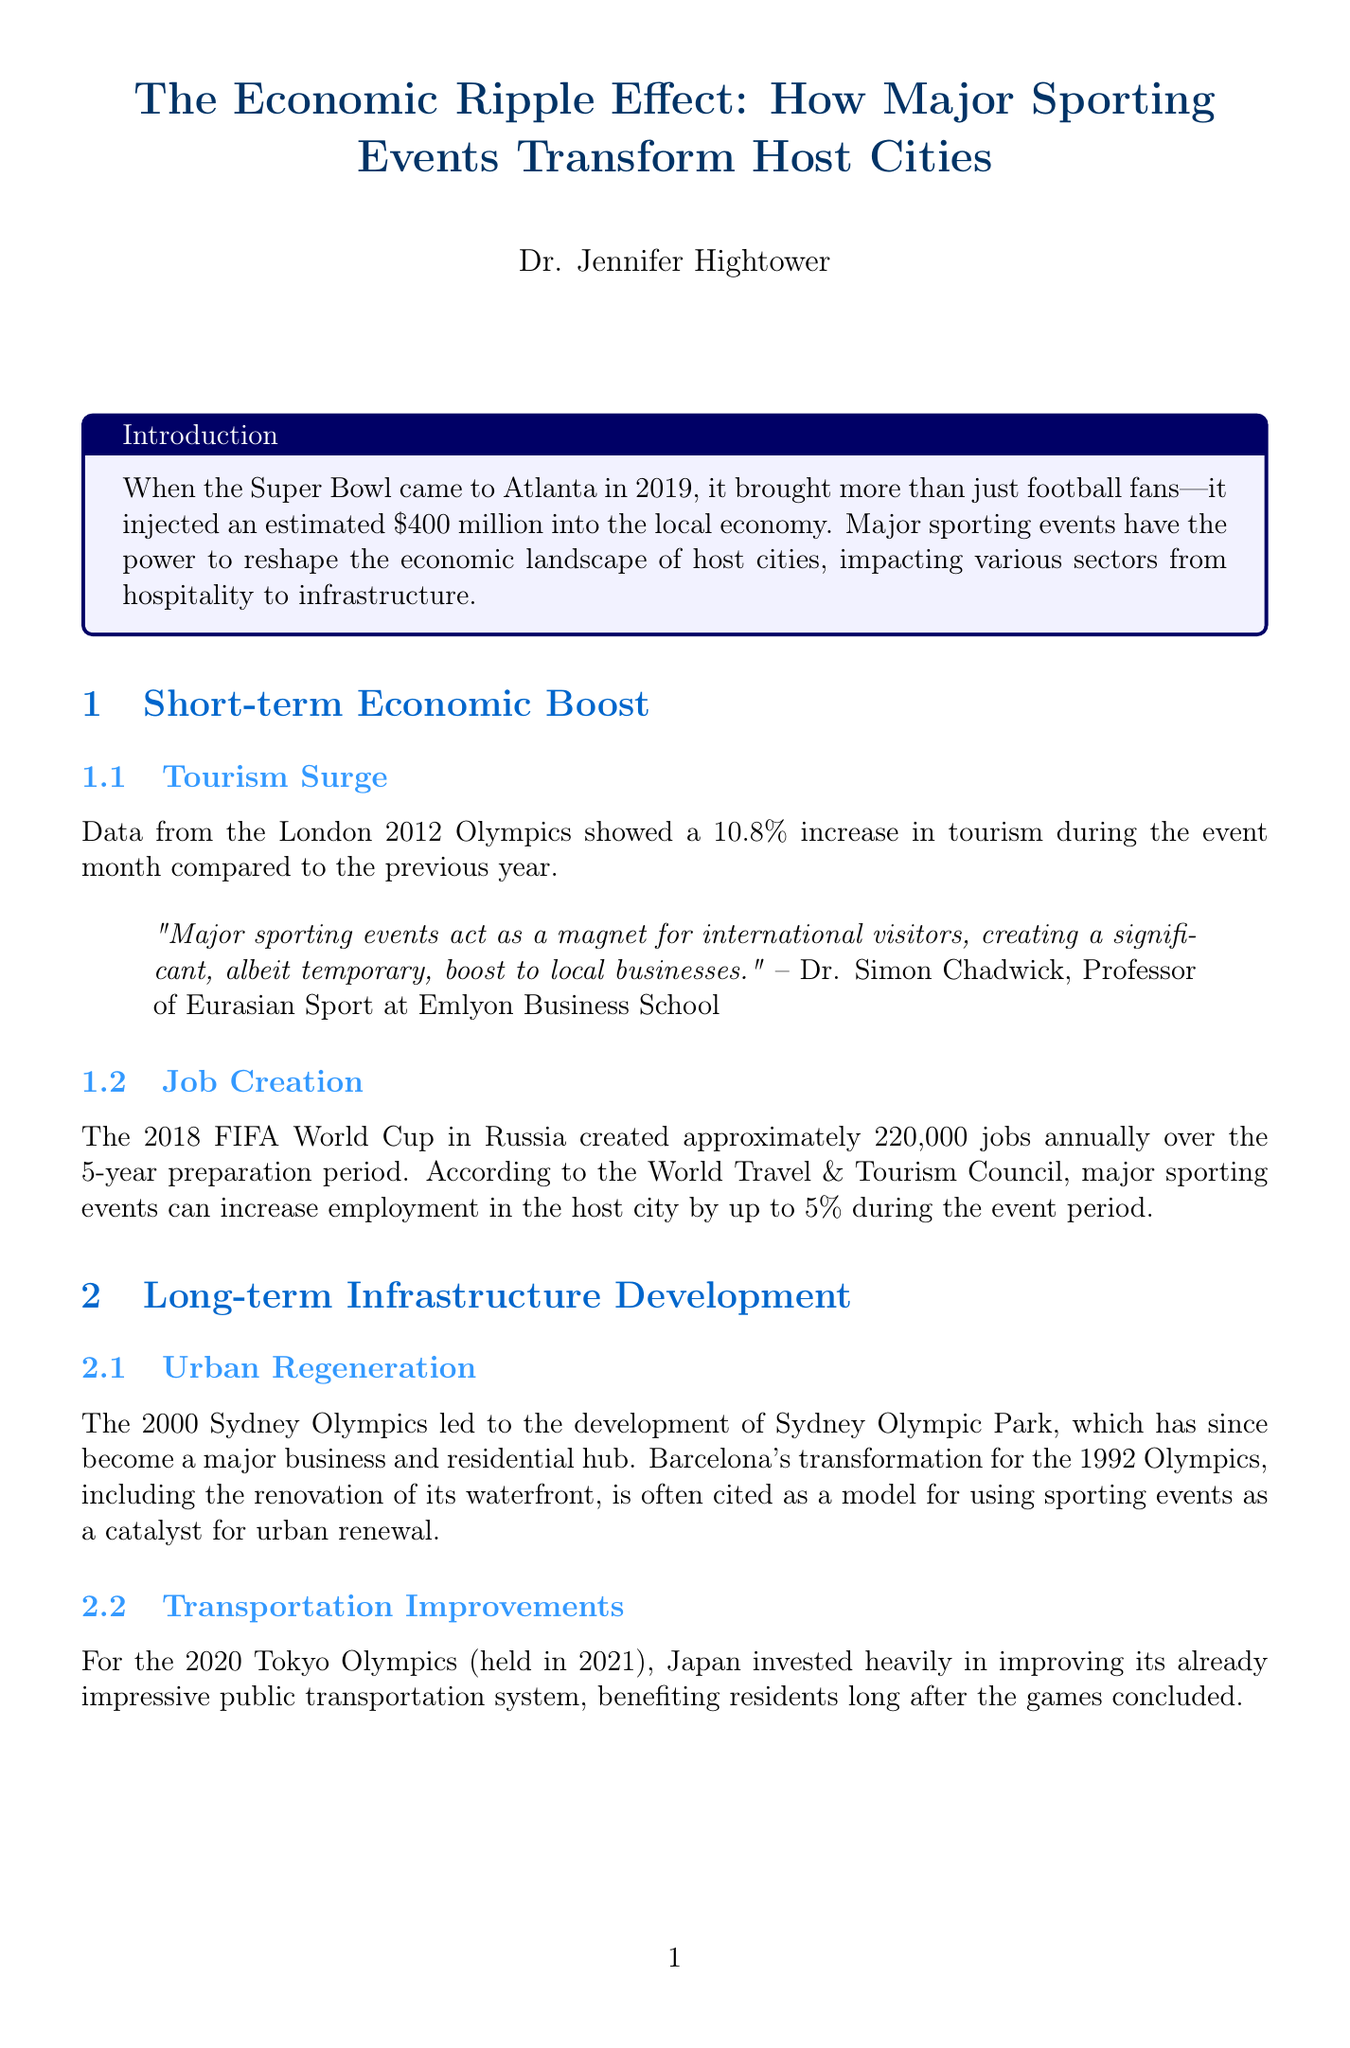What was the estimated economic injection from the Super Bowl in Atlanta? The document states that the Super Bowl injected an estimated $400 million into the local economy.
Answer: $400 million What percentage increase in tourism was recorded during the London 2012 Olympics? Data from the document shows a 10.8% increase in tourism during the event month compared to the previous year.
Answer: 10.8% How many jobs were created annually during the 2018 FIFA World Cup in Russia? The document mentions that the World Cup created approximately 220,000 jobs annually over the 5-year preparation period.
Answer: 220,000 What major development resulted from the 2000 Sydney Olympics? The document notes that the 2000 Sydney Olympics led to the development of Sydney Olympic Park, which became a major business and residential hub.
Answer: Sydney Olympic Park What is the term used for costly facilities that see little use after major events? The document states that the term "White Elephant Syndrome" refers to such facilities.
Answer: White Elephant Syndrome Who is the author of this report? The document clearly lists the author as Dr. Jennifer Hightower.
Answer: Dr. Jennifer Hightower What is the primary concern related to the 2014 Sochi Winter Olympics? The report highlights "Cost Overruns" as a primary concern due to the budget exceeding initial projections.
Answer: Cost Overruns How many people were reached by the global audience of the 2018 FIFA World Cup? The document indicates that the World Cup reached a global in-home television audience of 3.572 billion people.
Answer: 3.572 billion What is the document's conclusion regarding major sporting events? The conclusion emphasizes that success depends on careful planning, realistic expectations, and long-term strategies.
Answer: Success depends on careful planning 